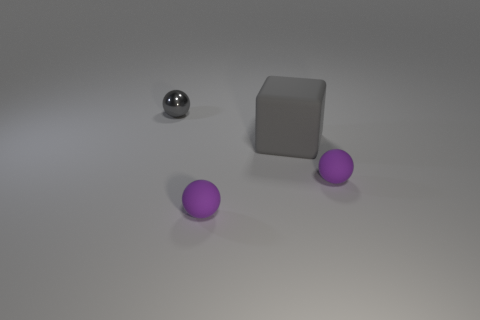Subtract all purple spheres. How many were subtracted if there are1purple spheres left? 1 Subtract all small matte spheres. How many spheres are left? 1 Subtract all gray spheres. How many spheres are left? 2 Add 2 spheres. How many objects exist? 6 Add 2 tiny things. How many tiny things exist? 5 Subtract 0 green balls. How many objects are left? 4 Subtract all balls. How many objects are left? 1 Subtract 1 spheres. How many spheres are left? 2 Subtract all green blocks. Subtract all red cylinders. How many blocks are left? 1 Subtract all red cylinders. How many gray balls are left? 1 